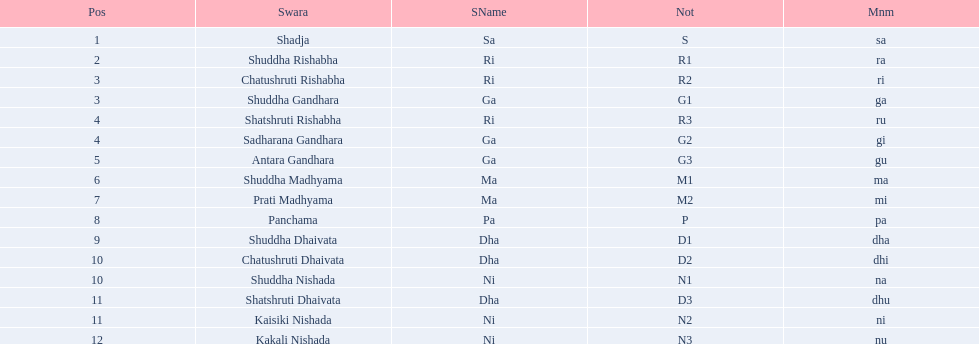Other than m1 how many notations have "1" in them? 4. 